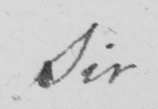Please transcribe the handwritten text in this image. Sir 